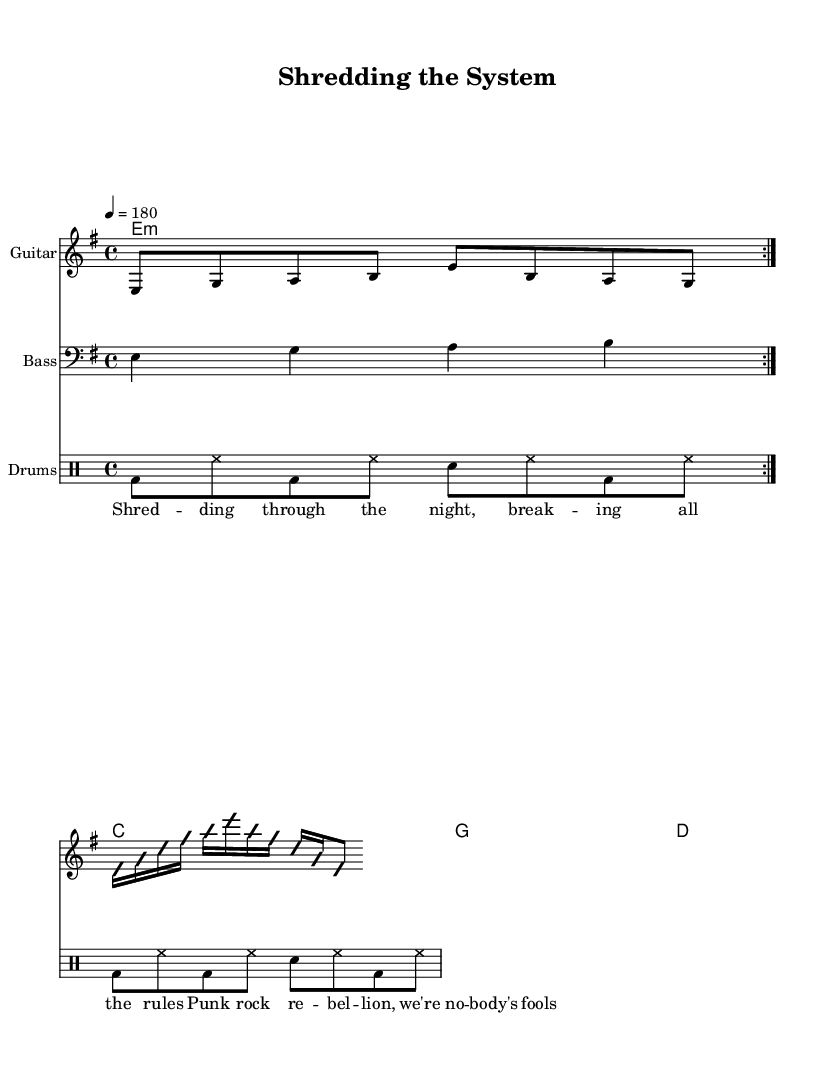What is the key signature of this music? The key signature shown in the music is E minor, which typically has one sharp (F#). This can be identified in the key signature section at the beginning of the staff.
Answer: E minor What is the time signature of this music? The time signature is 4/4, which can be seen at the beginning of the score. This indicates that there are four beats per measure, and a quarter note gets one beat.
Answer: 4/4 What is the tempo marking in the score? The tempo marking in the score indicates a tempo of quarter note equal to 180 beats per minute. This can be found in the tempo section written above the staff.
Answer: 180 How many times is the guitar riff repeated? The guitar riff is indicated to be repeated two times, as noted by the "repeat volta 2" instruction written above the riff section.
Answer: 2 What type of song structure is indicated by the use of the word "volta" in the scores? The use of "volta" indicates that there is a specific structure or a section intended to be repeated, specifically allowing certain parts to repeat while potentially leading to different sections strategically. This is common in punk rock to emphasize energy and dynamics.
Answer: Repeated sections How does the guitar solo express the influence of Eddie Van Halen? The guitar solo uses improvisation and techniques characteristic of Van Halen, such as fast picking and melodic phrases that include frequent string skipping, which are seen through various fast 16th notes and note patterns that create a dynamic and energetic feel.
Answer: Fast picking What lyrical theme is presented in this piece? The lyrics indicate themes of rebellion and breaking rules typical of punk rock, as highlighted in phrases like "breaking all the rules" and "punk rock rebellion." This theme resonates with punk culture and the genre's promotion of anti-establishment attitudes.
Answer: Rebellion 